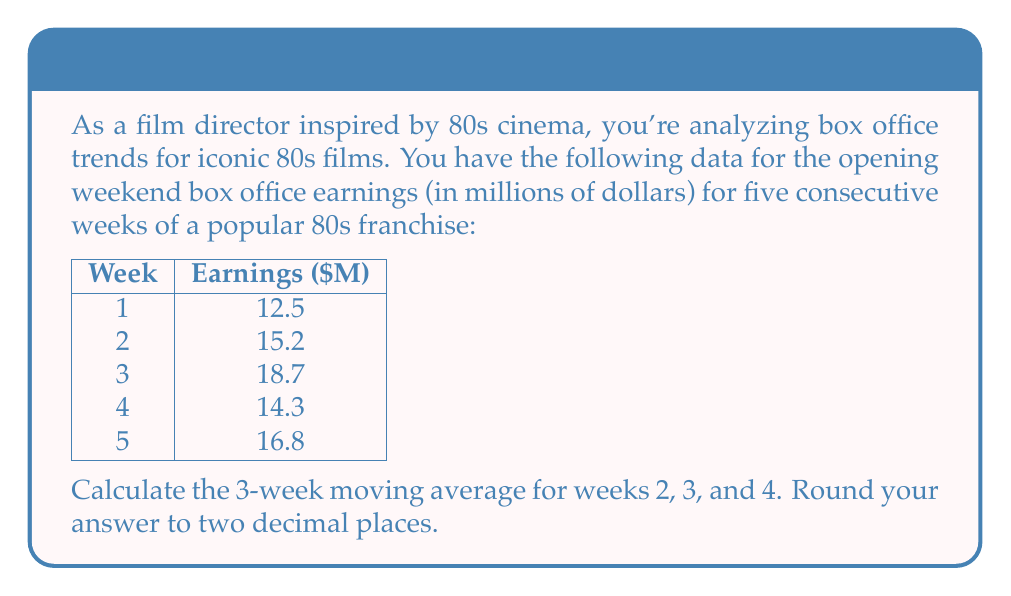Give your solution to this math problem. To calculate the 3-week moving average, we'll follow these steps:

1. Identify the data points for each 3-week period:
   - For Week 2: Weeks 1, 2, and 3
   - For Week 3: Weeks 2, 3, and 4
   - For Week 4: Weeks 3, 4, and 5

2. Calculate the average for each period:

   For Week 2:
   $$ \text{Average} = \frac{12.5 + 15.2 + 18.7}{3} = \frac{46.4}{3} = 15.47 $$

   For Week 3:
   $$ \text{Average} = \frac{15.2 + 18.7 + 14.3}{3} = \frac{48.2}{3} = 16.07 $$

   For Week 4:
   $$ \text{Average} = \frac{18.7 + 14.3 + 16.8}{3} = \frac{49.8}{3} = 16.60 $$

3. Round each result to two decimal places:
   - Week 2: 15.47 rounds to 15.47
   - Week 3: 16.07 rounds to 16.07
   - Week 4: 16.60 rounds to 16.60

Therefore, the 3-week moving averages for weeks 2, 3, and 4 are 15.47, 16.07, and 16.60 million dollars, respectively.
Answer: $15.47, $16.07, $16.60 